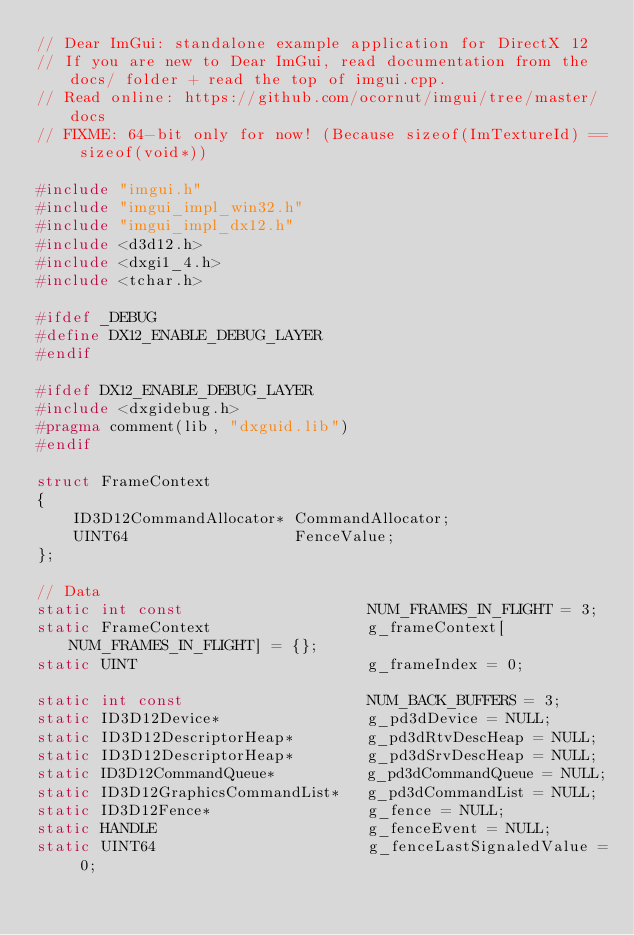Convert code to text. <code><loc_0><loc_0><loc_500><loc_500><_C++_>// Dear ImGui: standalone example application for DirectX 12
// If you are new to Dear ImGui, read documentation from the docs/ folder + read the top of imgui.cpp.
// Read online: https://github.com/ocornut/imgui/tree/master/docs
// FIXME: 64-bit only for now! (Because sizeof(ImTextureId) == sizeof(void*))

#include "imgui.h"
#include "imgui_impl_win32.h"
#include "imgui_impl_dx12.h"
#include <d3d12.h>
#include <dxgi1_4.h>
#include <tchar.h>

#ifdef _DEBUG
#define DX12_ENABLE_DEBUG_LAYER
#endif

#ifdef DX12_ENABLE_DEBUG_LAYER
#include <dxgidebug.h>
#pragma comment(lib, "dxguid.lib")
#endif

struct FrameContext
{
    ID3D12CommandAllocator* CommandAllocator;
    UINT64                  FenceValue;
};

// Data
static int const                    NUM_FRAMES_IN_FLIGHT = 3;
static FrameContext                 g_frameContext[NUM_FRAMES_IN_FLIGHT] = {};
static UINT                         g_frameIndex = 0;

static int const                    NUM_BACK_BUFFERS = 3;
static ID3D12Device*                g_pd3dDevice = NULL;
static ID3D12DescriptorHeap*        g_pd3dRtvDescHeap = NULL;
static ID3D12DescriptorHeap*        g_pd3dSrvDescHeap = NULL;
static ID3D12CommandQueue*          g_pd3dCommandQueue = NULL;
static ID3D12GraphicsCommandList*   g_pd3dCommandList = NULL;
static ID3D12Fence*                 g_fence = NULL;
static HANDLE                       g_fenceEvent = NULL;
static UINT64                       g_fenceLastSignaledValue = 0;</code> 